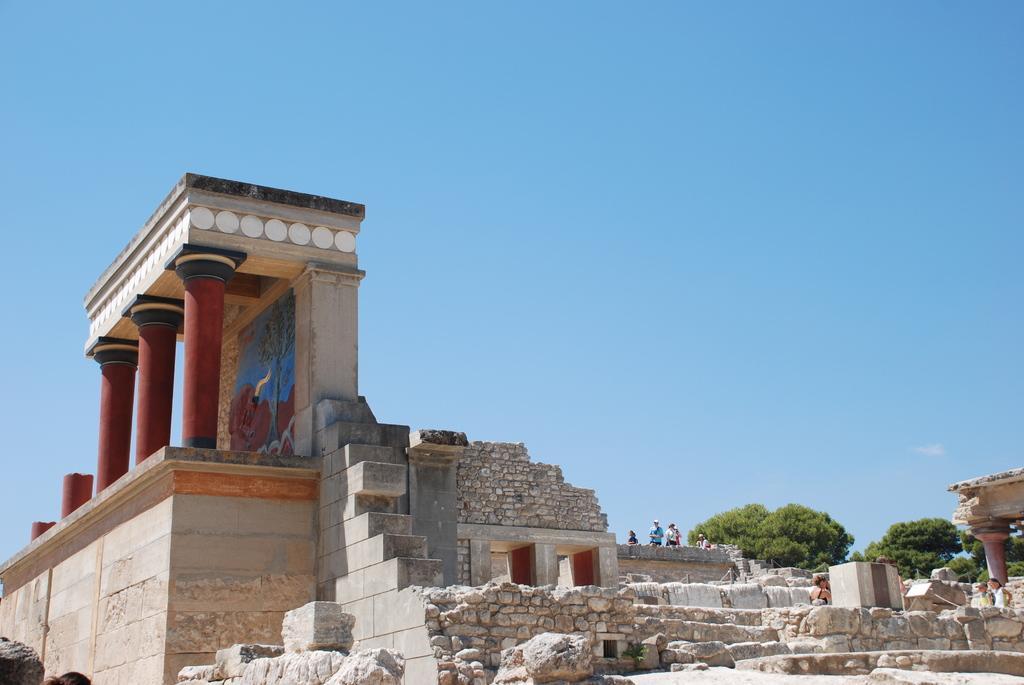How would you summarize this image in a sentence or two? In this picture there are people and we can see an ancient architecture, pillars, rocks and trees. In the background of the image we can see the sky. 